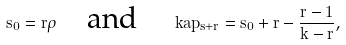<formula> <loc_0><loc_0><loc_500><loc_500>s _ { 0 } = r \rho \quad \text {and} \quad \ k a p _ { s + r } = s _ { 0 } + r - \frac { r - 1 } { k - r } ,</formula> 